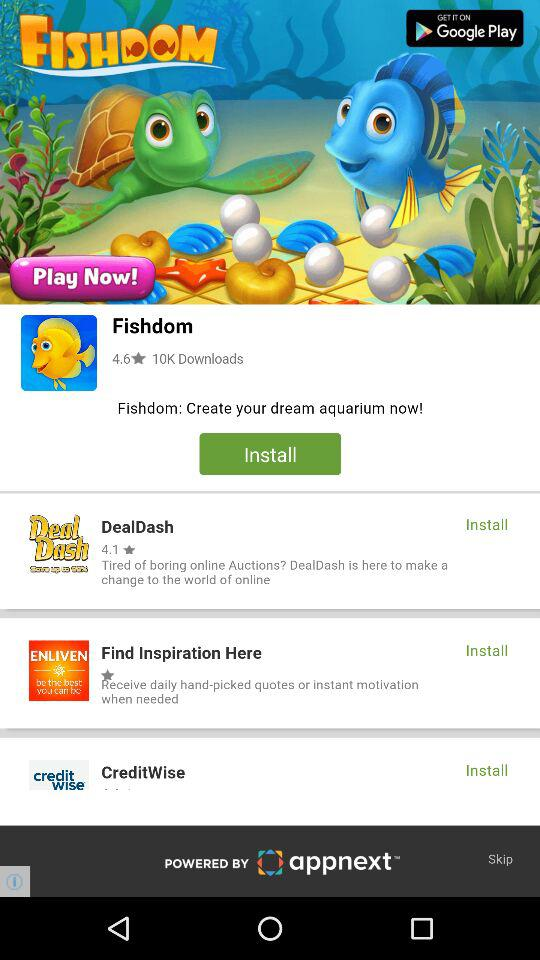Where can the application be located?
When the provided information is insufficient, respond with <no answer>. <no answer> 